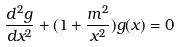<formula> <loc_0><loc_0><loc_500><loc_500>\frac { d ^ { 2 } g } { d x ^ { 2 } } + ( 1 + \frac { m ^ { 2 } } { x ^ { 2 } } ) g ( x ) = 0</formula> 